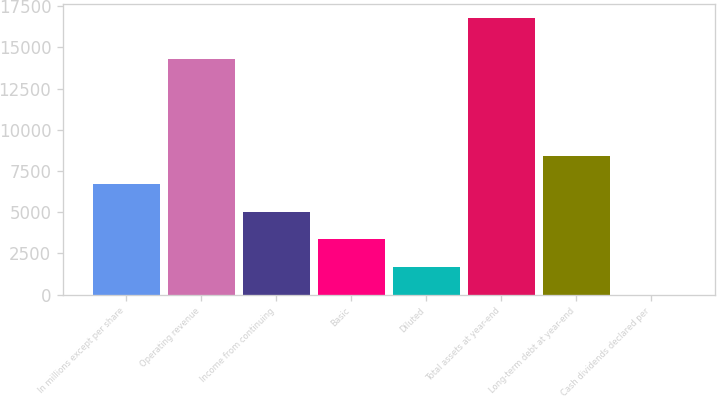Convert chart to OTSL. <chart><loc_0><loc_0><loc_500><loc_500><bar_chart><fcel>In millions except per share<fcel>Operating revenue<fcel>Income from continuing<fcel>Basic<fcel>Diluted<fcel>Total assets at year-end<fcel>Long-term debt at year-end<fcel>Cash dividends declared per<nl><fcel>6713.7<fcel>14314<fcel>5035.99<fcel>3358.28<fcel>1680.57<fcel>16780<fcel>8391.41<fcel>2.86<nl></chart> 